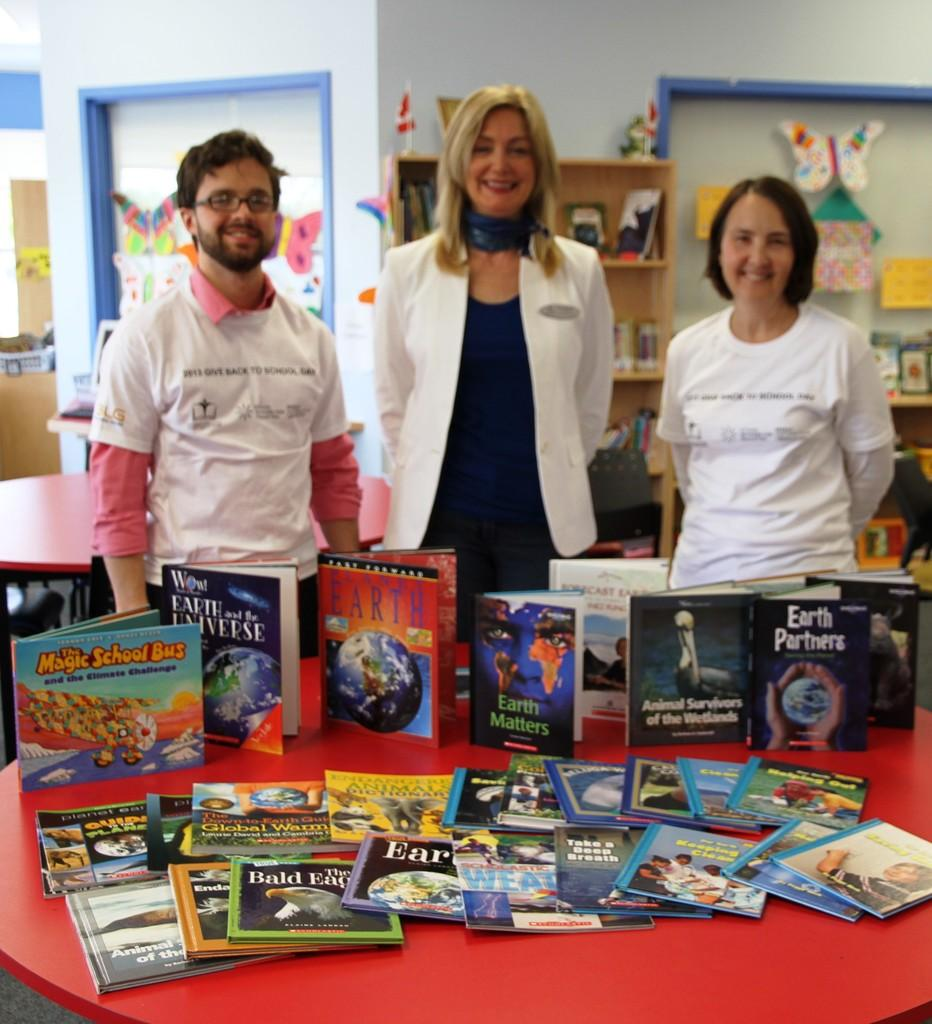<image>
Render a clear and concise summary of the photo. Some children's books, one of which is The Magic School Bus 